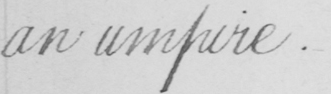Please transcribe the handwritten text in this image. an umpire . 